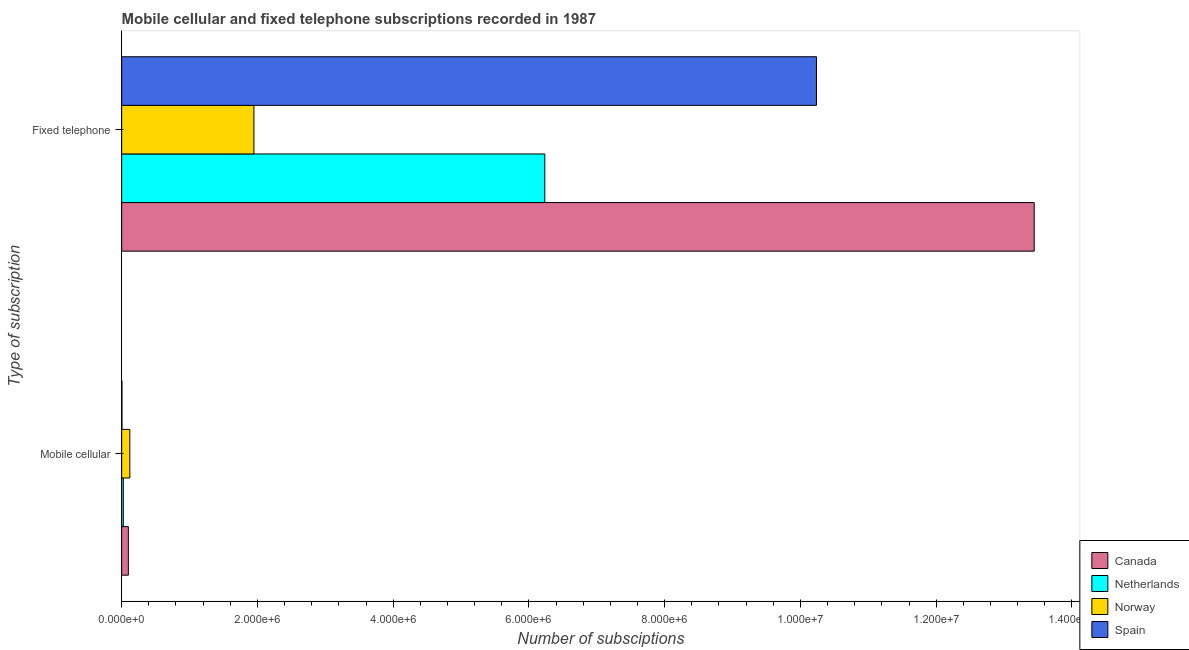How many different coloured bars are there?
Give a very brief answer. 4. Are the number of bars on each tick of the Y-axis equal?
Offer a very short reply. Yes. How many bars are there on the 1st tick from the top?
Your response must be concise. 4. What is the label of the 2nd group of bars from the top?
Offer a very short reply. Mobile cellular. What is the number of fixed telephone subscriptions in Spain?
Ensure brevity in your answer.  1.02e+07. Across all countries, what is the maximum number of fixed telephone subscriptions?
Provide a succinct answer. 1.34e+07. Across all countries, what is the minimum number of fixed telephone subscriptions?
Your response must be concise. 1.95e+06. In which country was the number of fixed telephone subscriptions maximum?
Provide a succinct answer. Canada. What is the total number of mobile cellular subscriptions in the graph?
Your answer should be very brief. 2.47e+05. What is the difference between the number of mobile cellular subscriptions in Spain and that in Canada?
Offer a very short reply. -9.42e+04. What is the difference between the number of mobile cellular subscriptions in Canada and the number of fixed telephone subscriptions in Norway?
Make the answer very short. -1.85e+06. What is the average number of fixed telephone subscriptions per country?
Ensure brevity in your answer.  7.97e+06. What is the difference between the number of fixed telephone subscriptions and number of mobile cellular subscriptions in Spain?
Your answer should be very brief. 1.02e+07. What is the ratio of the number of mobile cellular subscriptions in Netherlands to that in Norway?
Offer a very short reply. 0.2. In how many countries, is the number of fixed telephone subscriptions greater than the average number of fixed telephone subscriptions taken over all countries?
Provide a succinct answer. 2. What does the 4th bar from the top in Mobile cellular represents?
Make the answer very short. Canada. What is the difference between two consecutive major ticks on the X-axis?
Make the answer very short. 2.00e+06. Does the graph contain any zero values?
Offer a terse response. No. Does the graph contain grids?
Ensure brevity in your answer.  No. How are the legend labels stacked?
Your answer should be very brief. Vertical. What is the title of the graph?
Your answer should be compact. Mobile cellular and fixed telephone subscriptions recorded in 1987. Does "Cambodia" appear as one of the legend labels in the graph?
Ensure brevity in your answer.  No. What is the label or title of the X-axis?
Offer a terse response. Number of subsciptions. What is the label or title of the Y-axis?
Ensure brevity in your answer.  Type of subscription. What is the Number of subsciptions of Canada in Mobile cellular?
Offer a very short reply. 9.84e+04. What is the Number of subsciptions of Netherlands in Mobile cellular?
Provide a succinct answer. 2.42e+04. What is the Number of subsciptions of Norway in Mobile cellular?
Keep it short and to the point. 1.20e+05. What is the Number of subsciptions of Spain in Mobile cellular?
Make the answer very short. 4200. What is the Number of subsciptions of Canada in Fixed telephone?
Give a very brief answer. 1.34e+07. What is the Number of subsciptions in Netherlands in Fixed telephone?
Provide a succinct answer. 6.23e+06. What is the Number of subsciptions of Norway in Fixed telephone?
Your answer should be compact. 1.95e+06. What is the Number of subsciptions of Spain in Fixed telephone?
Offer a terse response. 1.02e+07. Across all Type of subscription, what is the maximum Number of subsciptions of Canada?
Offer a very short reply. 1.34e+07. Across all Type of subscription, what is the maximum Number of subsciptions of Netherlands?
Make the answer very short. 6.23e+06. Across all Type of subscription, what is the maximum Number of subsciptions in Norway?
Offer a very short reply. 1.95e+06. Across all Type of subscription, what is the maximum Number of subsciptions of Spain?
Make the answer very short. 1.02e+07. Across all Type of subscription, what is the minimum Number of subsciptions in Canada?
Your response must be concise. 9.84e+04. Across all Type of subscription, what is the minimum Number of subsciptions of Netherlands?
Provide a succinct answer. 2.42e+04. Across all Type of subscription, what is the minimum Number of subsciptions in Norway?
Provide a short and direct response. 1.20e+05. Across all Type of subscription, what is the minimum Number of subsciptions of Spain?
Your answer should be very brief. 4200. What is the total Number of subsciptions of Canada in the graph?
Provide a short and direct response. 1.35e+07. What is the total Number of subsciptions in Netherlands in the graph?
Offer a terse response. 6.26e+06. What is the total Number of subsciptions in Norway in the graph?
Provide a succinct answer. 2.07e+06. What is the total Number of subsciptions of Spain in the graph?
Provide a short and direct response. 1.02e+07. What is the difference between the Number of subsciptions in Canada in Mobile cellular and that in Fixed telephone?
Provide a succinct answer. -1.33e+07. What is the difference between the Number of subsciptions in Netherlands in Mobile cellular and that in Fixed telephone?
Your answer should be compact. -6.21e+06. What is the difference between the Number of subsciptions in Norway in Mobile cellular and that in Fixed telephone?
Provide a short and direct response. -1.83e+06. What is the difference between the Number of subsciptions in Spain in Mobile cellular and that in Fixed telephone?
Make the answer very short. -1.02e+07. What is the difference between the Number of subsciptions of Canada in Mobile cellular and the Number of subsciptions of Netherlands in Fixed telephone?
Offer a terse response. -6.14e+06. What is the difference between the Number of subsciptions in Canada in Mobile cellular and the Number of subsciptions in Norway in Fixed telephone?
Keep it short and to the point. -1.85e+06. What is the difference between the Number of subsciptions in Canada in Mobile cellular and the Number of subsciptions in Spain in Fixed telephone?
Your answer should be compact. -1.01e+07. What is the difference between the Number of subsciptions in Netherlands in Mobile cellular and the Number of subsciptions in Norway in Fixed telephone?
Keep it short and to the point. -1.92e+06. What is the difference between the Number of subsciptions in Netherlands in Mobile cellular and the Number of subsciptions in Spain in Fixed telephone?
Provide a short and direct response. -1.02e+07. What is the difference between the Number of subsciptions in Norway in Mobile cellular and the Number of subsciptions in Spain in Fixed telephone?
Offer a terse response. -1.01e+07. What is the average Number of subsciptions of Canada per Type of subscription?
Provide a succinct answer. 6.77e+06. What is the average Number of subsciptions of Netherlands per Type of subscription?
Your answer should be very brief. 3.13e+06. What is the average Number of subsciptions of Norway per Type of subscription?
Your response must be concise. 1.03e+06. What is the average Number of subsciptions in Spain per Type of subscription?
Make the answer very short. 5.12e+06. What is the difference between the Number of subsciptions in Canada and Number of subsciptions in Netherlands in Mobile cellular?
Provide a short and direct response. 7.42e+04. What is the difference between the Number of subsciptions of Canada and Number of subsciptions of Norway in Mobile cellular?
Your answer should be very brief. -2.17e+04. What is the difference between the Number of subsciptions of Canada and Number of subsciptions of Spain in Mobile cellular?
Give a very brief answer. 9.42e+04. What is the difference between the Number of subsciptions of Netherlands and Number of subsciptions of Norway in Mobile cellular?
Give a very brief answer. -9.58e+04. What is the difference between the Number of subsciptions in Norway and Number of subsciptions in Spain in Mobile cellular?
Your answer should be very brief. 1.16e+05. What is the difference between the Number of subsciptions in Canada and Number of subsciptions in Netherlands in Fixed telephone?
Your answer should be very brief. 7.21e+06. What is the difference between the Number of subsciptions in Canada and Number of subsciptions in Norway in Fixed telephone?
Your answer should be very brief. 1.15e+07. What is the difference between the Number of subsciptions in Canada and Number of subsciptions in Spain in Fixed telephone?
Provide a succinct answer. 3.21e+06. What is the difference between the Number of subsciptions in Netherlands and Number of subsciptions in Norway in Fixed telephone?
Your answer should be compact. 4.29e+06. What is the difference between the Number of subsciptions in Netherlands and Number of subsciptions in Spain in Fixed telephone?
Provide a short and direct response. -4.00e+06. What is the difference between the Number of subsciptions of Norway and Number of subsciptions of Spain in Fixed telephone?
Your answer should be compact. -8.29e+06. What is the ratio of the Number of subsciptions of Canada in Mobile cellular to that in Fixed telephone?
Provide a short and direct response. 0.01. What is the ratio of the Number of subsciptions of Netherlands in Mobile cellular to that in Fixed telephone?
Your answer should be very brief. 0. What is the ratio of the Number of subsciptions in Norway in Mobile cellular to that in Fixed telephone?
Your answer should be very brief. 0.06. What is the ratio of the Number of subsciptions of Spain in Mobile cellular to that in Fixed telephone?
Provide a succinct answer. 0. What is the difference between the highest and the second highest Number of subsciptions in Canada?
Provide a short and direct response. 1.33e+07. What is the difference between the highest and the second highest Number of subsciptions of Netherlands?
Keep it short and to the point. 6.21e+06. What is the difference between the highest and the second highest Number of subsciptions of Norway?
Give a very brief answer. 1.83e+06. What is the difference between the highest and the second highest Number of subsciptions in Spain?
Your answer should be very brief. 1.02e+07. What is the difference between the highest and the lowest Number of subsciptions of Canada?
Your answer should be very brief. 1.33e+07. What is the difference between the highest and the lowest Number of subsciptions in Netherlands?
Your answer should be very brief. 6.21e+06. What is the difference between the highest and the lowest Number of subsciptions in Norway?
Ensure brevity in your answer.  1.83e+06. What is the difference between the highest and the lowest Number of subsciptions of Spain?
Your answer should be compact. 1.02e+07. 